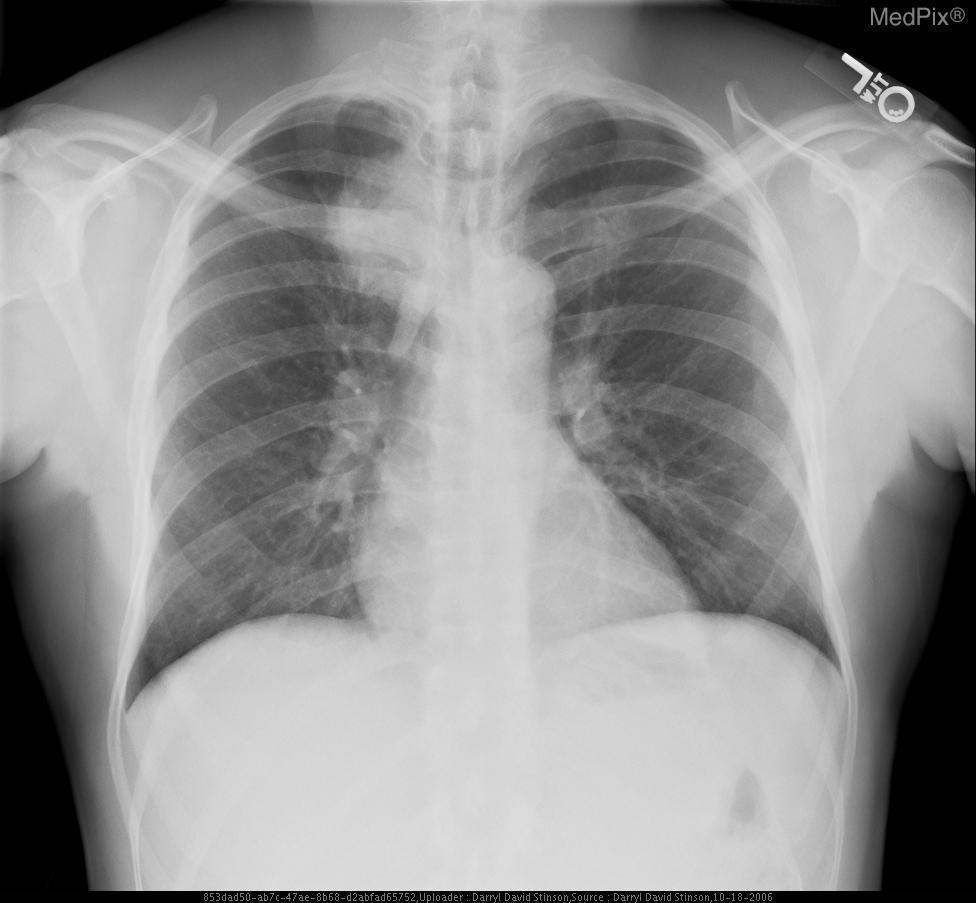What is the gender of this patient?
Keep it brief. Man. What is the abnormality?
Answer briefly. Right paratracheal mass lesion. What is wrong in this image?
Answer briefly. Right paratracheal mass lesion. What is the location of the abnormality?
Answer briefly. Right side of the trachea. Where is the abnormality?
Be succinct. Right side of the trachea. Is anything wrong in the image?
Short answer required. Yes. Is there an abnormality?
Quick response, please. Yes. 